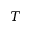Convert formula to latex. <formula><loc_0><loc_0><loc_500><loc_500>T</formula> 